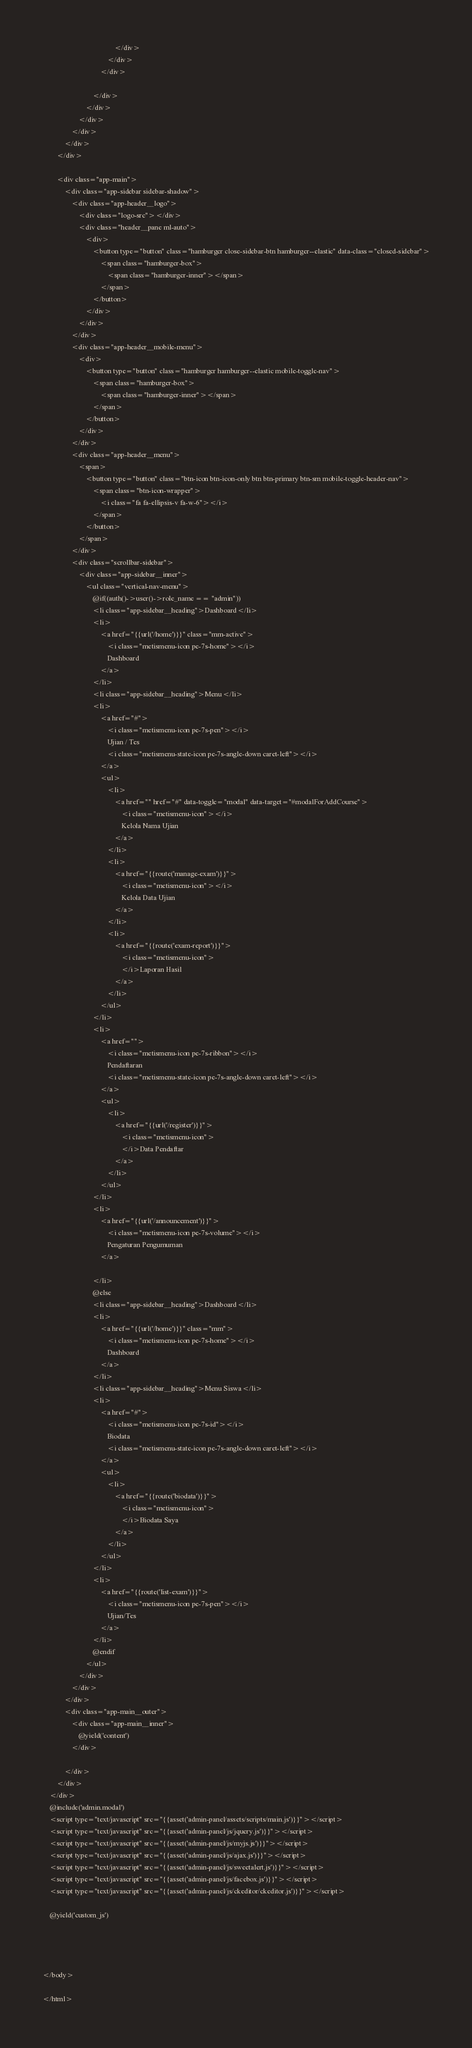<code> <loc_0><loc_0><loc_500><loc_500><_PHP_>                                        </div>
                                    </div>
                                </div>

                            </div>
                        </div>
                    </div>
                </div>
            </div>
        </div>

        <div class="app-main">
            <div class="app-sidebar sidebar-shadow">
                <div class="app-header__logo">
                    <div class="logo-src"></div>
                    <div class="header__pane ml-auto">
                        <div>
                            <button type="button" class="hamburger close-sidebar-btn hamburger--elastic" data-class="closed-sidebar">
                                <span class="hamburger-box">
                                    <span class="hamburger-inner"></span>
                                </span>
                            </button>
                        </div>
                    </div>
                </div>
                <div class="app-header__mobile-menu">
                    <div>
                        <button type="button" class="hamburger hamburger--elastic mobile-toggle-nav">
                            <span class="hamburger-box">
                                <span class="hamburger-inner"></span>
                            </span>
                        </button>
                    </div>
                </div>
                <div class="app-header__menu">
                    <span>
                        <button type="button" class="btn-icon btn-icon-only btn btn-primary btn-sm mobile-toggle-header-nav">
                            <span class="btn-icon-wrapper">
                                <i class="fa fa-ellipsis-v fa-w-6"></i>
                            </span>
                        </button>
                    </span>
                </div>
                <div class="scrollbar-sidebar">
                    <div class="app-sidebar__inner">
                        <ul class="vertical-nav-menu">
                            @if((auth()->user()->role_name == "admin"))
                            <li class="app-sidebar__heading">Dashboard</li>
                            <li>
                                <a href="{{url('/home')}}" class="mm-active">
                                    <i class="metismenu-icon pe-7s-home"></i>
                                    Dashboard
                                </a>
                            </li>
                            <li class="app-sidebar__heading">Menu</li>
                            <li>
                                <a href="#">
                                    <i class="metismenu-icon pe-7s-pen"></i>
                                    Ujian / Tes
                                    <i class="metismenu-state-icon pe-7s-angle-down caret-left"></i>
                                </a>
                                <ul>
                                    <li>
                                        <a href="" href="#" data-toggle="modal" data-target="#modalForAddCourse">
                                            <i class="metismenu-icon"></i>
                                            Kelola Nama Ujian
                                        </a>
                                    </li>
                                    <li>
                                        <a href="{{route('manage-exam')}}">
                                            <i class="metismenu-icon"></i>
                                            Kelola Data Ujian
                                        </a>
                                    </li>
                                    <li>
                                        <a href="{{route('exam-report')}}">
                                            <i class="metismenu-icon">
                                            </i>Laporan Hasil
                                        </a>
                                    </li>
                                </ul>
                            </li>
                            <li>
                                <a href="">
                                    <i class="metismenu-icon pe-7s-ribbon"></i>
                                    Pendaftaran
                                    <i class="metismenu-state-icon pe-7s-angle-down caret-left"></i>
                                </a>
                                <ul>
                                    <li>
                                        <a href="{{url('/register')}}">
                                            <i class="metismenu-icon">
                                            </i>Data Pendaftar
                                        </a>
                                    </li>
                                </ul>
                            </li>
                            <li>
                                <a href="{{url('/announcement')}}">
                                    <i class="metismenu-icon pe-7s-volume"></i>
                                    Pengaturan Pengumuman
                                </a>

                            </li>
                            @else
                            <li class="app-sidebar__heading">Dashboard</li>
                            <li>
                                <a href="{{url('/home')}}" class="mm">
                                    <i class="metismenu-icon pe-7s-home"></i>
                                    Dashboard
                                </a>
                            </li>
                            <li class="app-sidebar__heading">Menu Siswa</li>
                            <li>
                                <a href="#">
                                    <i class="metismenu-icon pe-7s-id"></i>
                                    Biodata
                                    <i class="metismenu-state-icon pe-7s-angle-down caret-left"></i>
                                </a>
                                <ul>
                                    <li>
                                        <a href="{{route('biodata')}}">
                                            <i class="metismenu-icon">
                                            </i>Biodata Saya
                                        </a>
                                    </li>
                                </ul>
                            </li>
                            <li>
                                <a href="{{route('list-exam')}}">
                                    <i class="metismenu-icon pe-7s-pen"></i>
                                    Ujian/Tes
                                </a>
                            </li>
                            @endif
                        </ul>
                    </div>
                </div>
            </div>
            <div class="app-main__outer">
                <div class="app-main__inner">
                    @yield('content')
                </div>

            </div>
        </div>
    </div>
    @include('admin.modal')
    <script type="text/javascript" src="{{asset('admin-panel/assets/scripts/main.js')}}"></script>
    <script type="text/javascript" src="{{asset('admin-panel/js/jquery.js')}}"></script>
    <script type="text/javascript" src="{{asset('admin-panel/js/myjs.js')}}"></script>
    <script type="text/javascript" src="{{asset('admin-panel/js/ajax.js')}}"></script>
    <script type="text/javascript" src="{{asset('admin-panel/js/sweetalert.js')}}"></script>
    <script type="text/javascript" src="{{asset('admin-panel/js/facebox.js')}}"></script>
    <script type="text/javascript" src="{{asset('admin-panel/js/ckeditor/ckeditor.js')}}"></script>

    @yield('custom_js')

    


</body>

</html></code> 